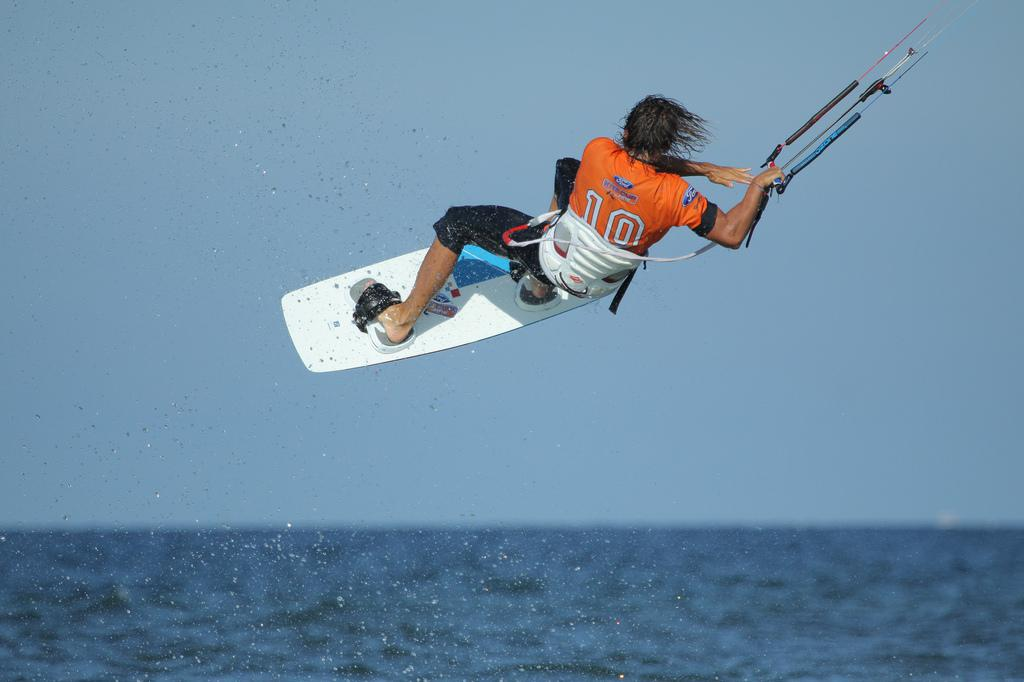Question: who has short pants?
Choices:
A. All the people.
B. The man.
C. The child.
D. A woman.
Answer with the letter. Answer: B Question: what sport is this?
Choices:
A. Baseball.
B. Kitesurfing.
C. Bascketball.
D. Foot ball.
Answer with the letter. Answer: B Question: why is he holding onto that handle?
Choices:
A. It's the parachute.
B. To open the door.
C. To turn off the main power.
D. To open the drawer.
Answer with the letter. Answer: A Question: where is the waves?
Choices:
A. Not many waves.
B. The beach.
C. The lake.
D. The river.
Answer with the letter. Answer: A Question: what number is on the orange shirt?
Choices:
A. 10.
B. 11.
C. 15.
D. 88.
Answer with the letter. Answer: A Question: how is the weather?
Choices:
A. Warm.
B. Clear and sunny.
C. It's outdoor weather.
D. Beautiful weather.
Answer with the letter. Answer: B Question: who has a tan?
Choices:
A. The woman.
B. The man.
C. The child.
D. Everyone.
Answer with the letter. Answer: B Question: what color is the sky?
Choices:
A. Blue.
B. Grey.
C. Yellow.
D. Brown.
Answer with the letter. Answer: A 